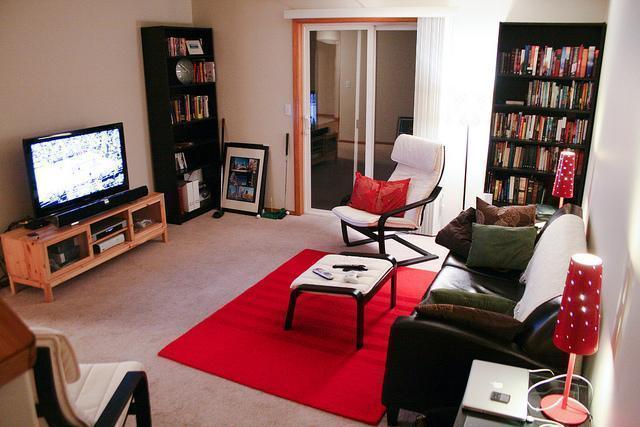What is the black couch against the wall made out of?
Select the accurate answer and provide explanation: 'Answer: answer
Rationale: rationale.'
Options: Wool, denim, nylon, leather. Answer: leather.
Rationale: This is the most common and durable material that furniture might be made with. 